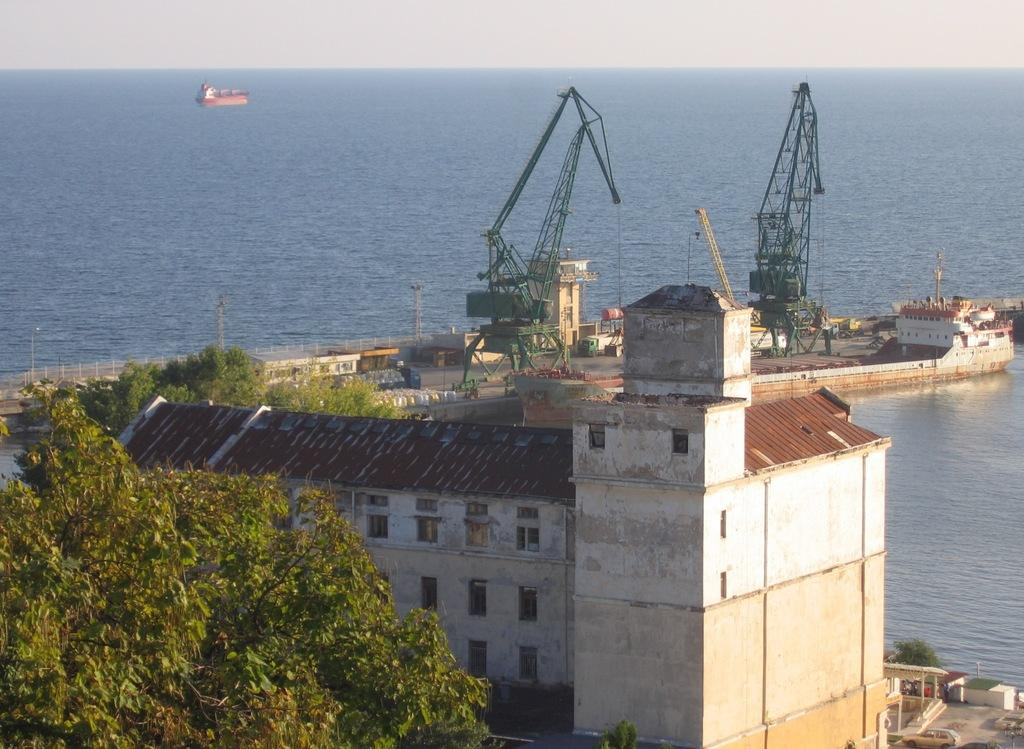What type of structures can be seen in the image? There are buildings in the image. What else is present in the image besides buildings? There are current polls, trees, water, vehicles, and a boat visible in the image. What type of vegetation is in the image? There are trees in the image. What can be seen in the water in the image? The image does not provide enough detail to determine what is in the water. What is visible at the top of the image? The sky is visible at the top of the image. What is the rate of the boat's speed in the image? The image does not provide any information about the boat's speed, so it is not possible to determine its rate. What example can be seen in the aftermath of the storm in the image? There is no storm or aftermath depicted in the image; it features buildings, current polls, trees, water, vehicles, and a boat. 